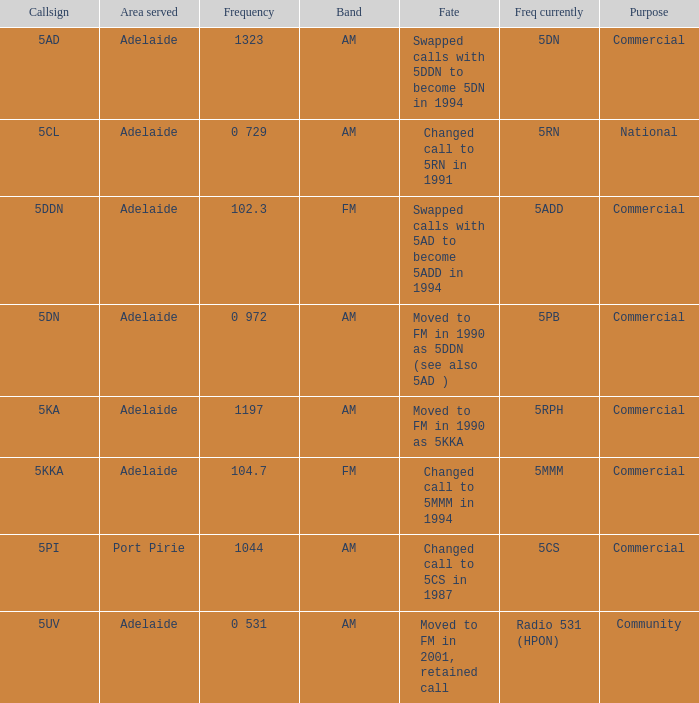What is the purpose for Frequency of 102.3? Commercial. 